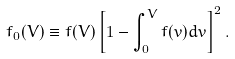Convert formula to latex. <formula><loc_0><loc_0><loc_500><loc_500>f _ { 0 } ( V ) \equiv f ( V ) \left [ 1 - \int _ { 0 } ^ { V } f ( v ) d v \right ] ^ { 2 } .</formula> 